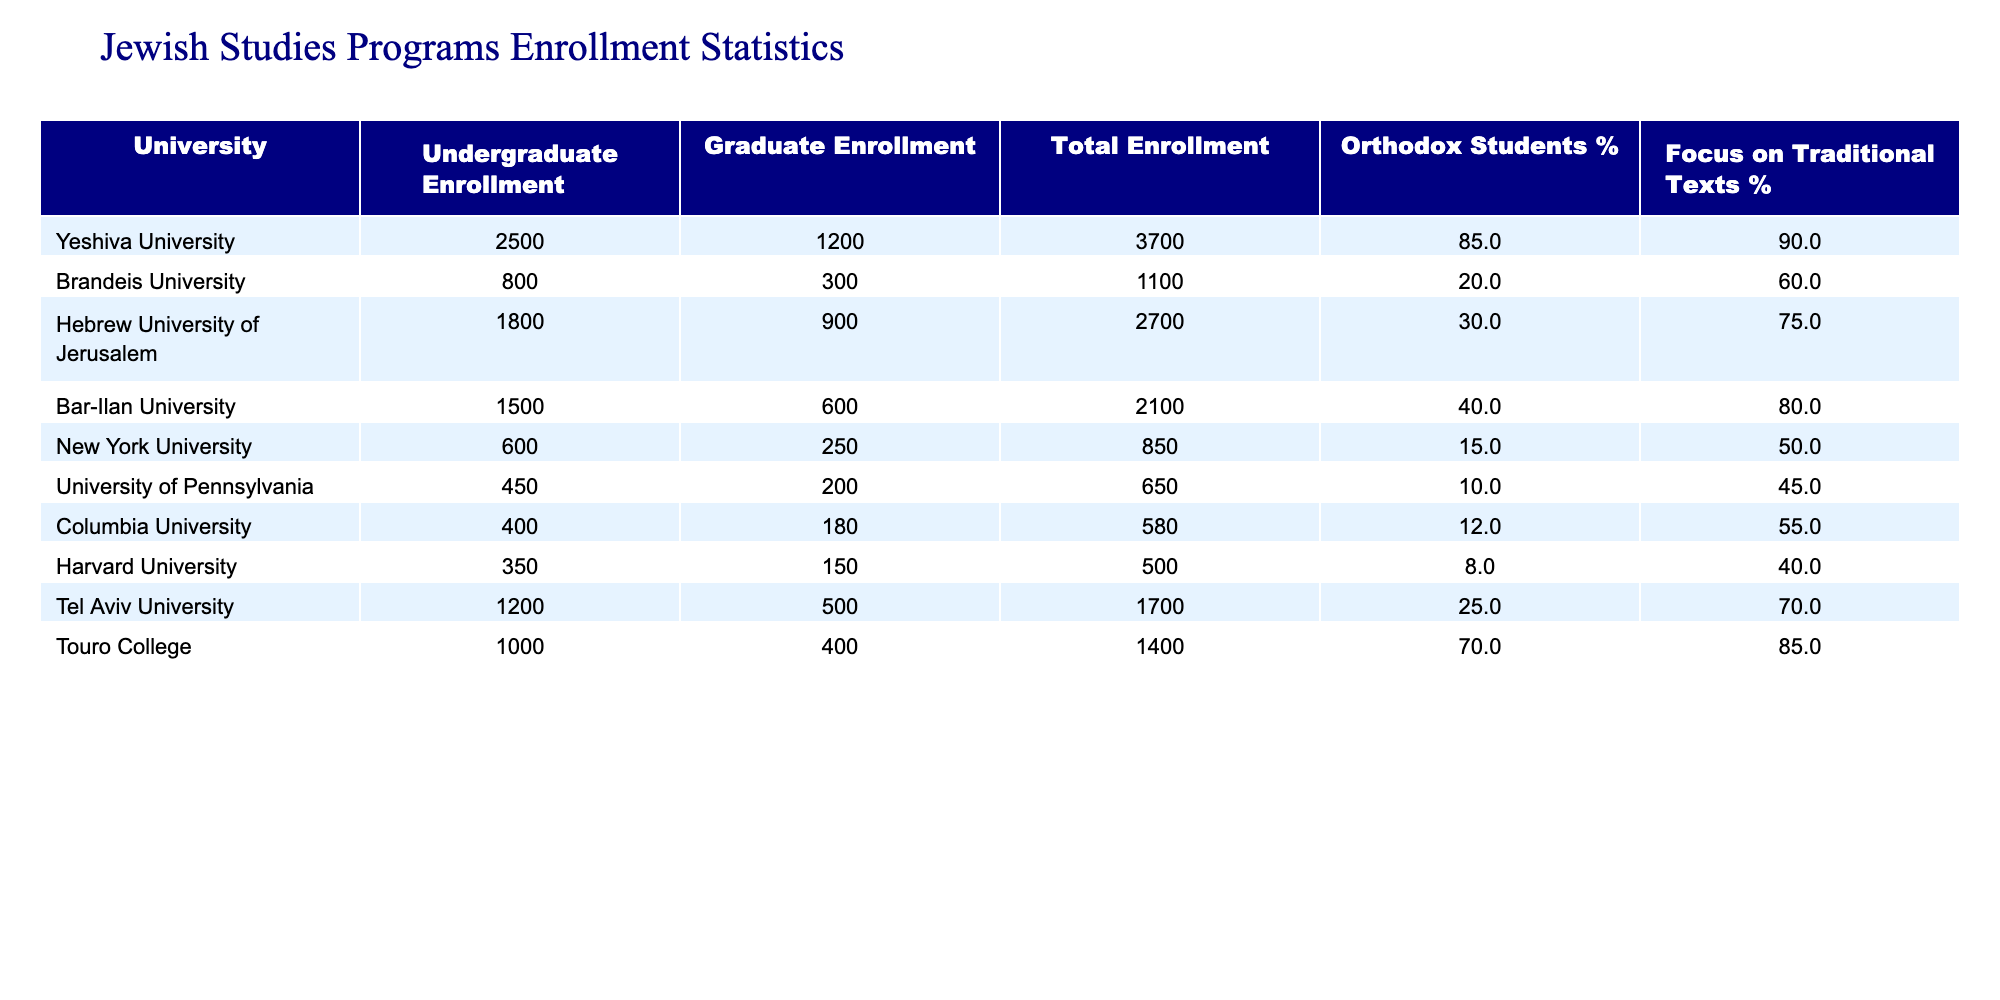What is the total enrollment at Yeshiva University? To find the total enrollment at Yeshiva University, we look at the "Total Enrollment" column for this university, which shows 3700.
Answer: 3700 Which university has the highest percentage of Orthodox students? By examining the "Orthodox Students %" column, we see that Yeshiva University has the highest percentage at 85%.
Answer: Yeshiva University What is the total enrollment across all universities listed? We need to sum the "Total Enrollment" values from all universities: 3700 + 1100 + 2700 + 2100 + 850 + 650 + 580 + 500 + 1700 + 1400 = 12,980.
Answer: 12980 What is the average percentage of students focusing on traditional texts across all universities? We first sum the "Focus on Traditional Texts %" values: 90 + 60 + 75 + 80 + 50 + 45 + 55 + 40 + 70 + 85 = 710. Then, divide by the number of universities (10): 710 / 10 = 71.
Answer: 71 Is it true that Harvard University has more graduate students than undergraduate students? By checking the enrollment numbers, we see that Harvard has 350 undergraduate students and 150 graduate students, so this statement is false.
Answer: No Which university has the lowest total enrollment? Looking at the "Total Enrollment" column, University of Pennsylvania has the lowest total enrollment with 650 students.
Answer: University of Pennsylvania What percentage of students at Touro College focus on traditional texts? In the "Focus on Traditional Texts %" column, Touro College shows a percentage of 85%.
Answer: 85 How many graduate students are enrolled at Brandeis University? According to the "Graduate Enrollment" column, Brandeis University has 300 graduate students enrolled.
Answer: 300 What is the difference in total enrollment between Yeshiva University and Hebrew University of Jerusalem? To find the difference, subtract the total enrollment of Hebrew University (2700) from Yeshiva University (3700): 3700 - 2700 = 1000.
Answer: 1000 Which university has the least percentage of Orthodox students? Checking the "Orthodox Students %" column, Harvard University has the least percentage at 8%.
Answer: Harvard University 